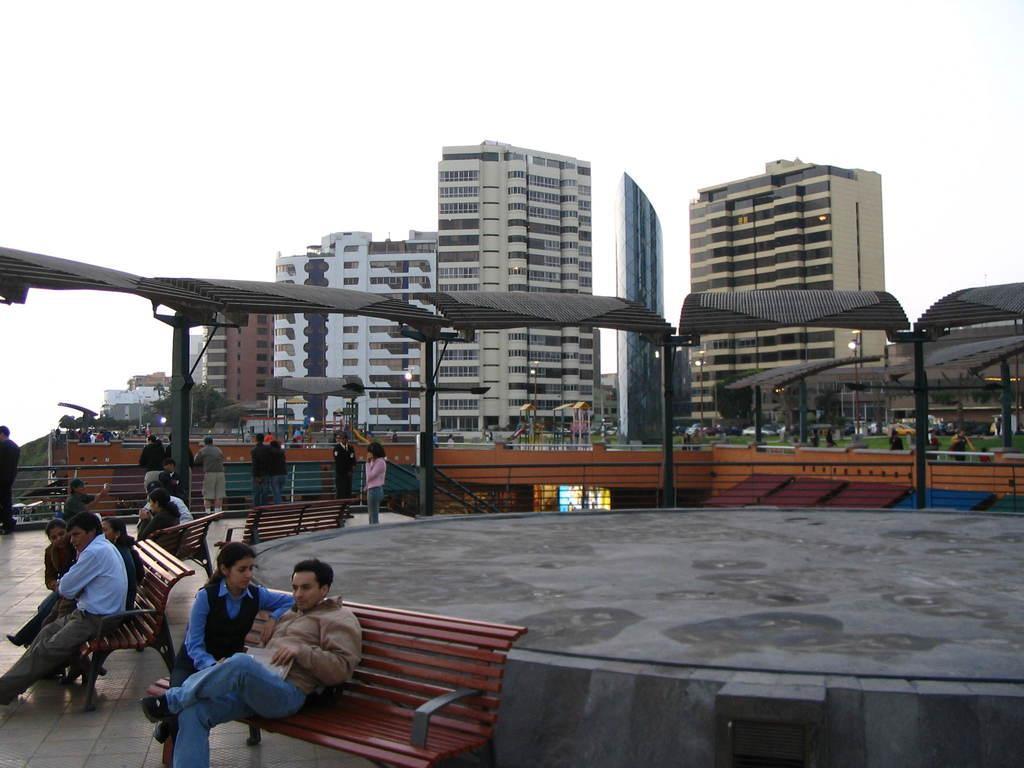Could you give a brief overview of what you see in this image? A image is taken outside of the city. In the image there are group of people sitting on bench and remaining people are standing. In background there are buildings and sky is on top. 